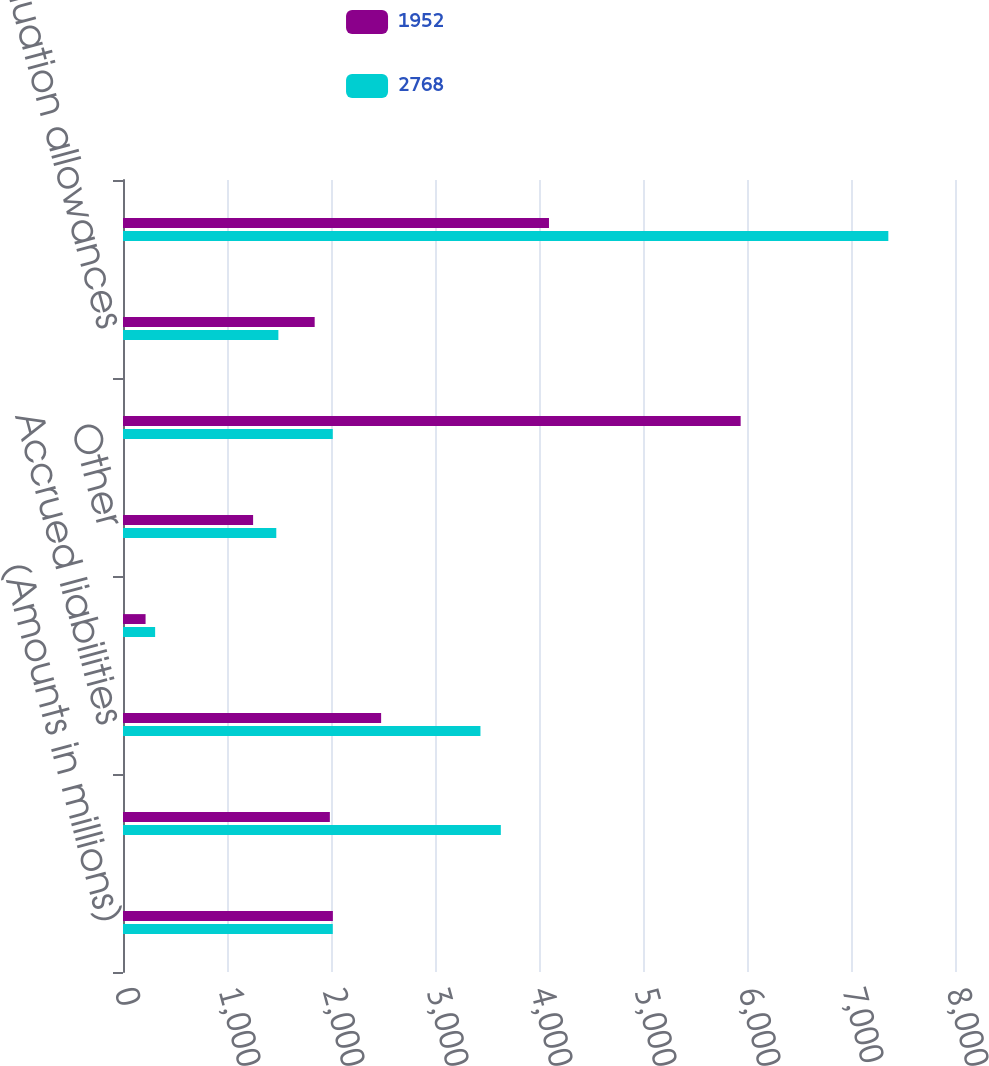Convert chart to OTSL. <chart><loc_0><loc_0><loc_500><loc_500><stacked_bar_chart><ecel><fcel>(Amounts in millions)<fcel>Loss and tax credit<fcel>Accrued liabilities<fcel>Share-based compensation<fcel>Other<fcel>Total deferred tax assets<fcel>Valuation allowances<fcel>Deferred tax assets net of<nl><fcel>1952<fcel>2018<fcel>1989<fcel>2482<fcel>217<fcel>1251<fcel>5939<fcel>1843<fcel>4096<nl><fcel>2768<fcel>2017<fcel>3633<fcel>3437<fcel>309<fcel>1474<fcel>2017<fcel>1494<fcel>7359<nl></chart> 